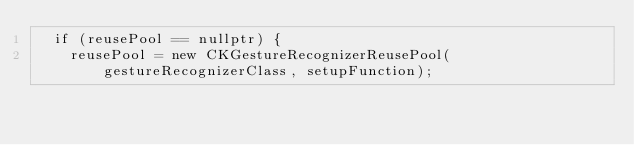Convert code to text. <code><loc_0><loc_0><loc_500><loc_500><_ObjectiveC_>  if (reusePool == nullptr) {
    reusePool = new CKGestureRecognizerReusePool(gestureRecognizerClass, setupFunction);</code> 